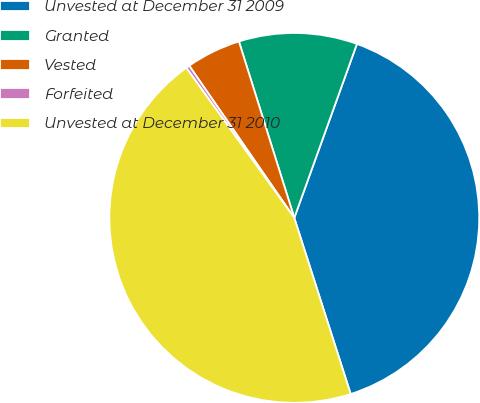Convert chart. <chart><loc_0><loc_0><loc_500><loc_500><pie_chart><fcel>Unvested at December 31 2009<fcel>Granted<fcel>Vested<fcel>Forfeited<fcel>Unvested at December 31 2010<nl><fcel>39.57%<fcel>10.34%<fcel>4.78%<fcel>0.31%<fcel>45.01%<nl></chart> 